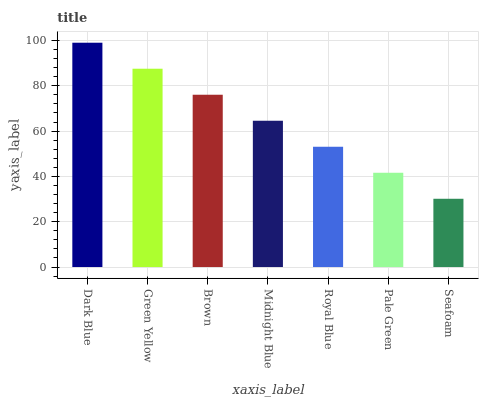Is Seafoam the minimum?
Answer yes or no. Yes. Is Dark Blue the maximum?
Answer yes or no. Yes. Is Green Yellow the minimum?
Answer yes or no. No. Is Green Yellow the maximum?
Answer yes or no. No. Is Dark Blue greater than Green Yellow?
Answer yes or no. Yes. Is Green Yellow less than Dark Blue?
Answer yes or no. Yes. Is Green Yellow greater than Dark Blue?
Answer yes or no. No. Is Dark Blue less than Green Yellow?
Answer yes or no. No. Is Midnight Blue the high median?
Answer yes or no. Yes. Is Midnight Blue the low median?
Answer yes or no. Yes. Is Dark Blue the high median?
Answer yes or no. No. Is Brown the low median?
Answer yes or no. No. 